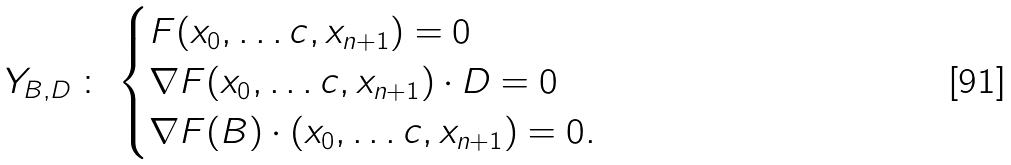<formula> <loc_0><loc_0><loc_500><loc_500>Y _ { B , D } \, \colon \, \begin{cases} F ( x _ { 0 } , \dots c , x _ { n + 1 } ) = 0 \\ \nabla { F } ( x _ { 0 } , \dots c , x _ { n + 1 } ) \cdot D = 0 \\ \nabla { F } ( B ) \cdot ( x _ { 0 } , \dots c , x _ { n + 1 } ) = 0 . \end{cases}</formula> 